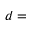Convert formula to latex. <formula><loc_0><loc_0><loc_500><loc_500>d =</formula> 